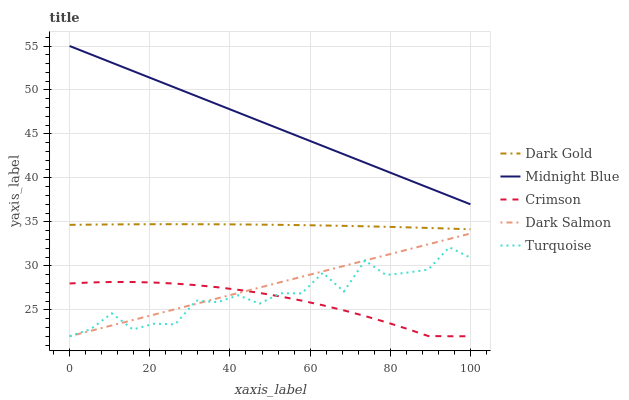Does Crimson have the minimum area under the curve?
Answer yes or no. Yes. Does Midnight Blue have the maximum area under the curve?
Answer yes or no. Yes. Does Turquoise have the minimum area under the curve?
Answer yes or no. No. Does Turquoise have the maximum area under the curve?
Answer yes or no. No. Is Dark Salmon the smoothest?
Answer yes or no. Yes. Is Turquoise the roughest?
Answer yes or no. Yes. Is Turquoise the smoothest?
Answer yes or no. No. Is Dark Salmon the roughest?
Answer yes or no. No. Does Midnight Blue have the lowest value?
Answer yes or no. No. Does Midnight Blue have the highest value?
Answer yes or no. Yes. Does Turquoise have the highest value?
Answer yes or no. No. Is Crimson less than Midnight Blue?
Answer yes or no. Yes. Is Midnight Blue greater than Turquoise?
Answer yes or no. Yes. Does Turquoise intersect Dark Salmon?
Answer yes or no. Yes. Is Turquoise less than Dark Salmon?
Answer yes or no. No. Is Turquoise greater than Dark Salmon?
Answer yes or no. No. Does Crimson intersect Midnight Blue?
Answer yes or no. No. 